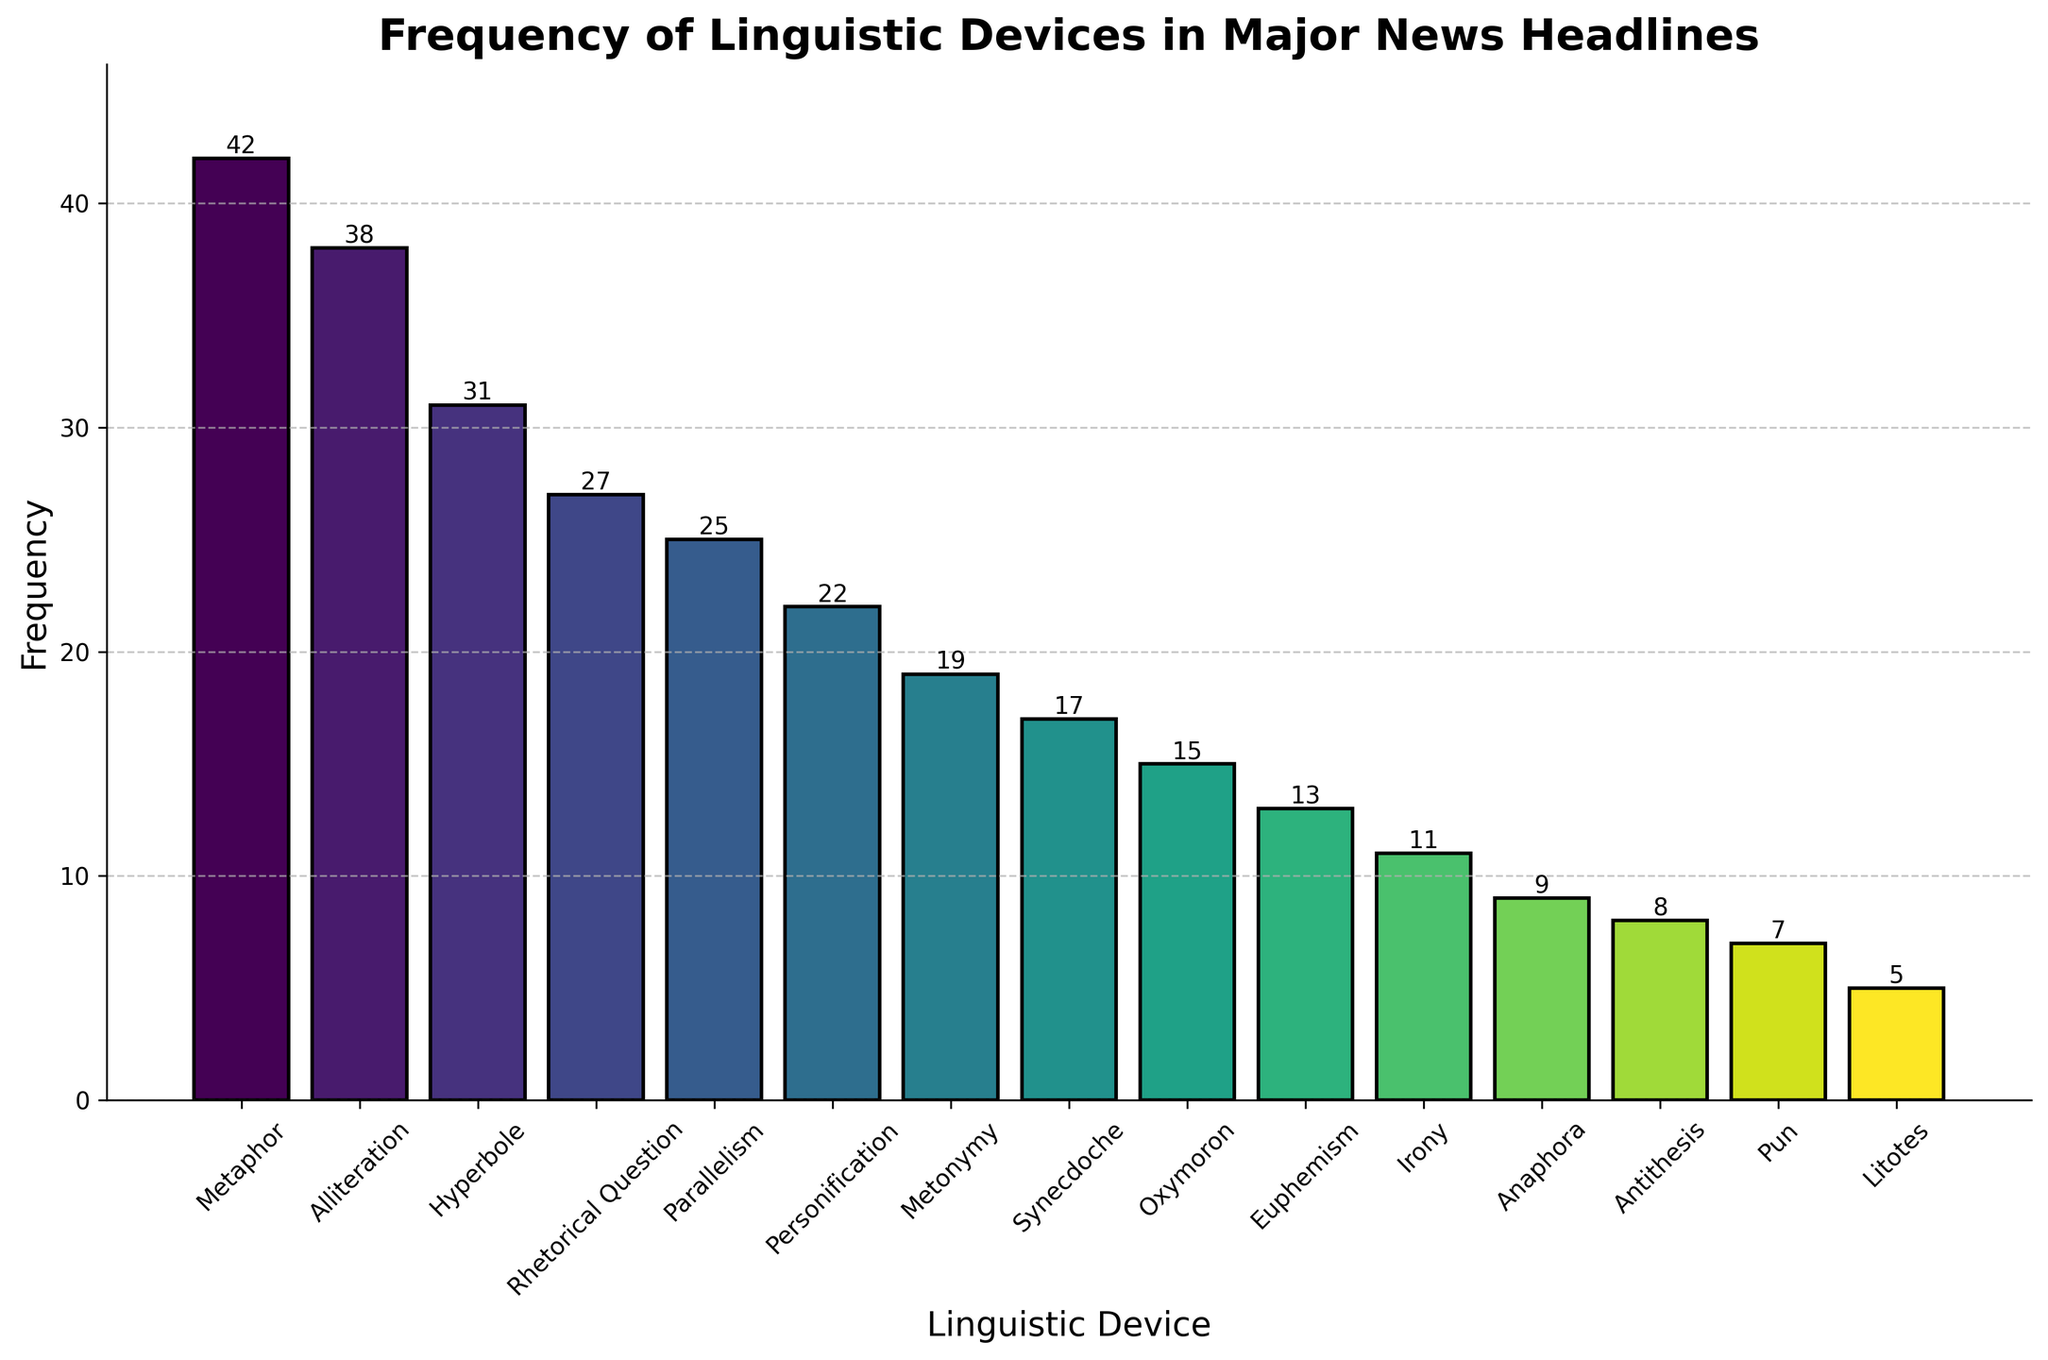What's the most frequently used linguistic device in major news headlines? The tallest bar in the bar chart represents the most frequently used linguistic device. From the figure, the tallest bar corresponds to Metaphor.
Answer: Metaphor Which linguistic device is used the least frequently in major news headlines? The shortest bar represents the least frequently used device. The shortest bar corresponds to Litotes.
Answer: Litotes What's the sum of the frequencies of Metaphor and Alliteration? Refer to the heights of the bars for Metaphor and Alliteration. Metaphor has a frequency of 42 and Alliteration has a frequency of 38. Sum them up: 42 + 38 = 80.
Answer: 80 How much more frequently is Metaphor used compared to Euphemism? Find the difference in heights between Metaphor and Euphemism. Metaphor has a frequency of 42 and Euphemism has a frequency of 13. Subtract the two: 42 - 13 = 29.
Answer: 29 Which linguistic device has the median frequency? To determine the median, list the frequencies in ascending order: 5, 7, 8, 9, 11, 13, 15, 17, 19, 22, 25, 27, 31, 38, 42. The median value is the middle one, which is 17, corresponding to Synecdoche.
Answer: Synecdoche Which two linguistic devices have the closest frequency values? Visually compare the heights of adjacent bars. The devices with the smallest difference in height are Synecdoche (17) and Metonymy (19).
Answer: Synecdoche and Metonymy What's the average frequency of all linguistic devices? Sum all the frequencies and divide by the number of devices. Sum = 42 + 38 + 31 + 27 + 25 + 22 + 19 + 17 + 15 + 13 + 11 + 9 + 8 + 7 + 5 = 288. There are 15 devices, so the average is 288 / 15 = 19.2.
Answer: 19.2 How does the frequency of Irony compare to that of Personification? Compare the heights of the bars for Irony and Personification. Irony has a frequency of 11, and Personification has a frequency of 22. Irony is used less frequently by a difference of 22 - 11 = 11.
Answer: Irony is used 11 times less frequently than Personification What's the frequency range of the linguistic devices displayed in the chart? The range is the difference between the maximum and minimum frequencies. The maximum frequency is 42 (Metaphor) and the minimum is 5 (Litotes). Range = 42 - 5 = 37.
Answer: 37 